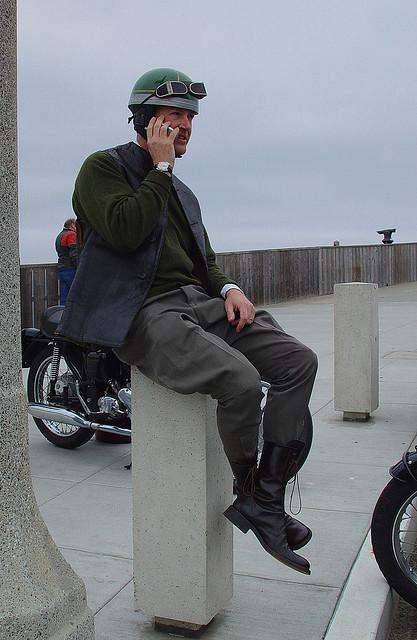The man sitting on the post with the phone to his ear is wearing what color of dome on his hat? green 